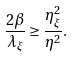Convert formula to latex. <formula><loc_0><loc_0><loc_500><loc_500>\frac { 2 \beta } { \lambda _ { \xi } } \geq \frac { \eta _ { \xi } ^ { 2 } } { \eta ^ { 2 } } .</formula> 